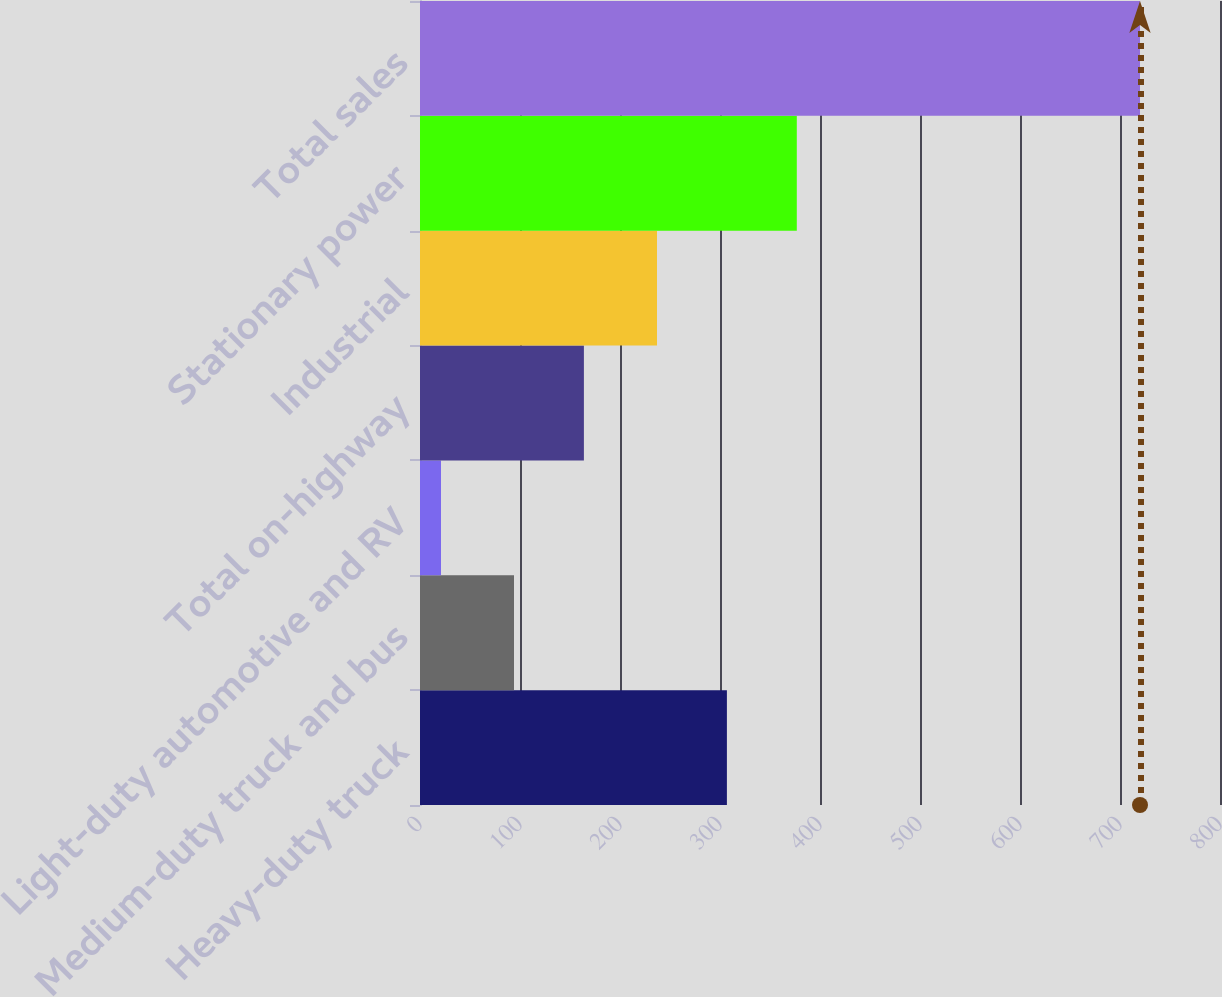<chart> <loc_0><loc_0><loc_500><loc_500><bar_chart><fcel>Heavy-duty truck<fcel>Medium-duty truck and bus<fcel>Light-duty automotive and RV<fcel>Total on-highway<fcel>Industrial<fcel>Stationary power<fcel>Total sales<nl><fcel>306.9<fcel>94<fcel>21<fcel>163.9<fcel>237<fcel>376.8<fcel>720<nl></chart> 